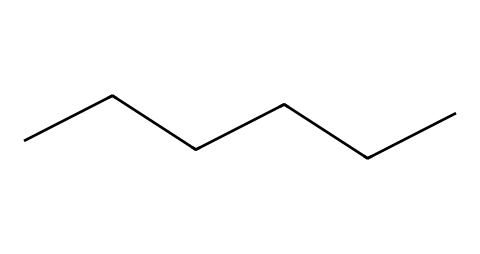How many carbon atoms are in hexane? The SMILES representation "CCCCCC" indicates a straight-chain hydrocarbon with six carbon atoms connected in a row. Each "C" represents a carbon atom, and there are six of them in total.
Answer: six What is the molecular formula of hexane? Hexane consists of six carbon atoms and fourteen hydrogen atoms. The general formula for an alkane is CnH(2n+2). For n=6, that gives us C6H14.
Answer: C6H14 Is hexane a saturated or unsaturated compound? The structure "CCCCCC" denotes a straight-chain hydrocarbon where all carbon-carbon bonds are single, indicating that it is saturated. Saturated compounds have the maximum number of hydrogen atoms bonded to the carbon skeleton.
Answer: saturated What is the common use of hexane in industry? Hexane is primarily used as a solvent in the extraction of oils and fats from vegetables and in various chemical processes. Its non-polarity makes it effective for this purpose.
Answer: solvent How many hydrogen atoms are connected to the terminal carbon atoms in hexane? In a straight-chain alkane like hexane, the terminal carbon atoms (the first and last "C" in the chain) each have three hydrogen atoms bonded to them, while internal carbon atoms have two. Hence, each terminal carbon has three hydrogen atoms attached.
Answer: three What type of chemical bond predominates in hexane? In hexane, the bonds between the carbon atoms are all single bonds, which are indicated by the chain format without any double or triple bonds. These single bonds are characteristic of saturated hydrocarbons.
Answer: single bond How volatile is hexane compared to other solvents? Hexane has a relatively high volatility compared to other solvents due to its low boiling point (about 68.7 °C or 155.7 °F). This property enables it to evaporate quickly at room temperature.
Answer: high volatile 